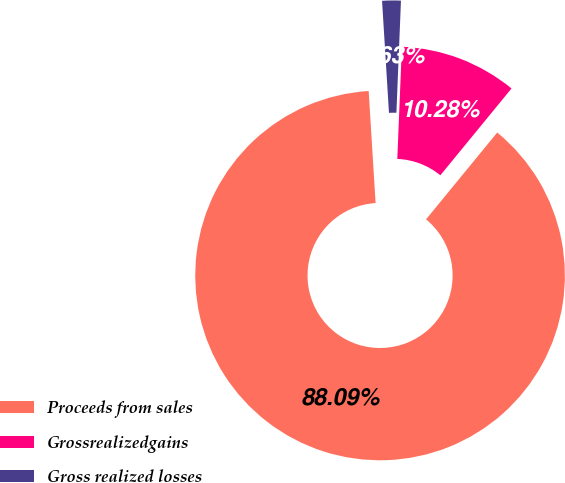<chart> <loc_0><loc_0><loc_500><loc_500><pie_chart><fcel>Proceeds from sales<fcel>Grossrealizedgains<fcel>Gross realized losses<nl><fcel>88.09%<fcel>10.28%<fcel>1.63%<nl></chart> 